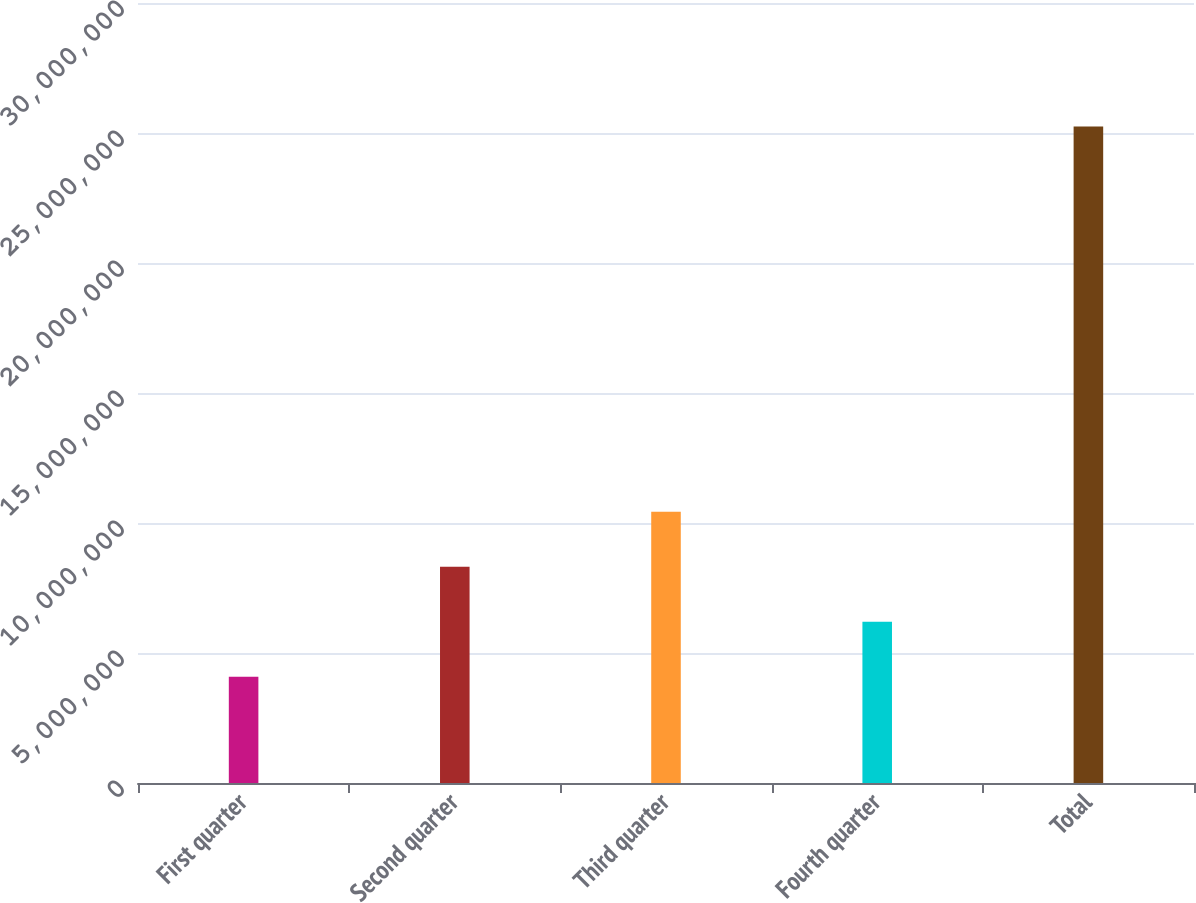<chart> <loc_0><loc_0><loc_500><loc_500><bar_chart><fcel>First quarter<fcel>Second quarter<fcel>Third quarter<fcel>Fourth quarter<fcel>Total<nl><fcel>4.088e+06<fcel>8.31981e+06<fcel>1.04357e+07<fcel>6.2039e+06<fcel>2.5247e+07<nl></chart> 